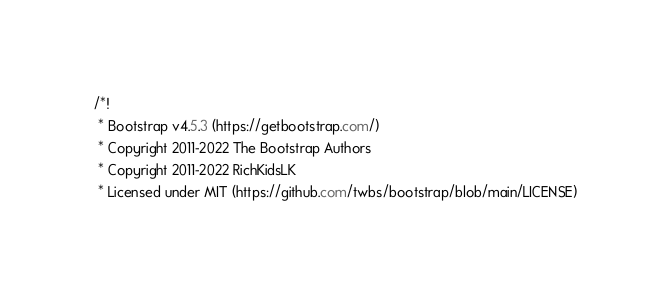Convert code to text. <code><loc_0><loc_0><loc_500><loc_500><_CSS_>/*!
 * Bootstrap v4.5.3 (https://getbootstrap.com/)
 * Copyright 2011-2022 The Bootstrap Authors
 * Copyright 2011-2022 RichKidsLK
 * Licensed under MIT (https://github.com/twbs/bootstrap/blob/main/LICENSE)</code> 